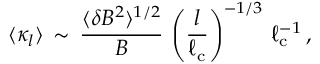<formula> <loc_0><loc_0><loc_500><loc_500>\langle { \kappa _ { l } } \rangle \, \sim \, \frac { \langle \delta B ^ { 2 } \rangle ^ { 1 / 2 } } { B } \, \left ( \frac { l } { \ell _ { c } } \right ) ^ { - 1 / 3 } \, \ell _ { c } ^ { - 1 } \, ,</formula> 